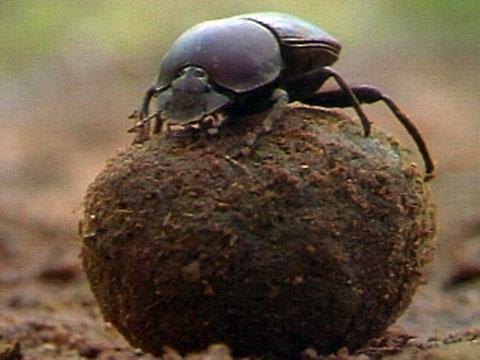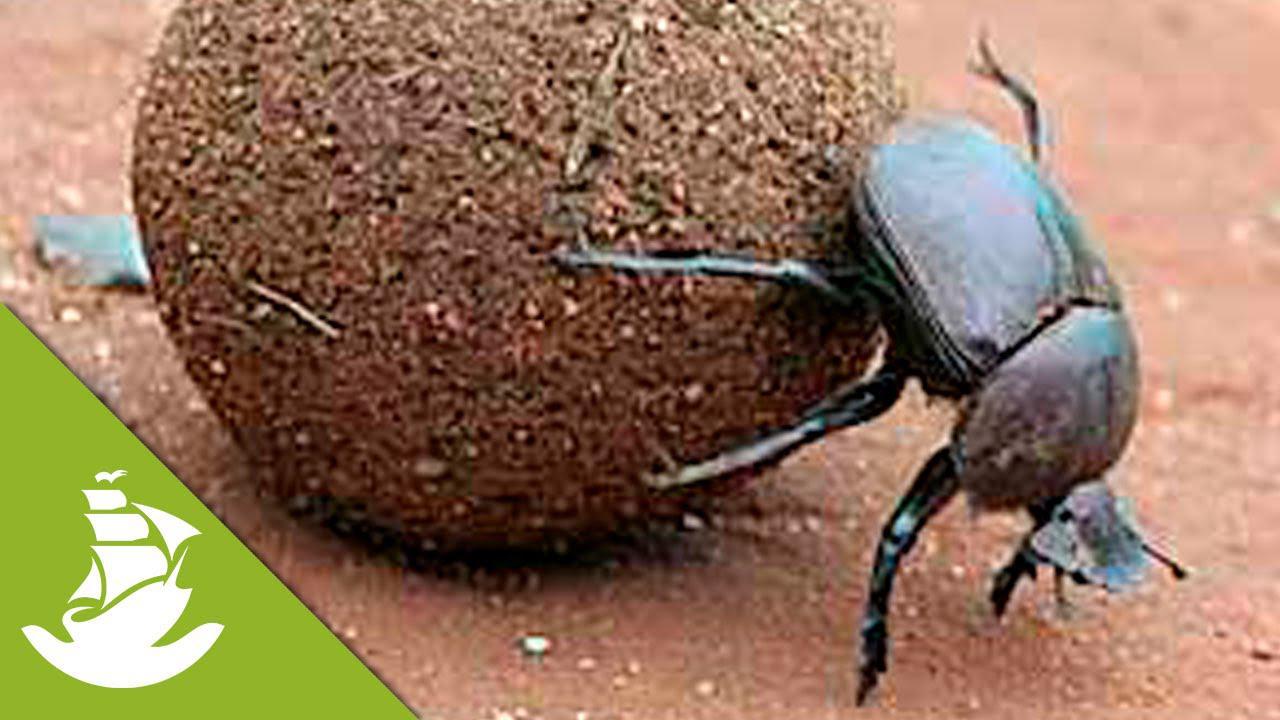The first image is the image on the left, the second image is the image on the right. Considering the images on both sides, is "In one of the images, more than one beetle is seen, interacting with the 'ball'." valid? Answer yes or no. No. The first image is the image on the left, the second image is the image on the right. Analyze the images presented: Is the assertion "There are no more than two dung beetles." valid? Answer yes or no. Yes. The first image is the image on the left, the second image is the image on the right. Examine the images to the left and right. Is the description "An image shows a beetle standing directly on top of a dung ball, with its body horizontal." accurate? Answer yes or no. Yes. The first image is the image on the left, the second image is the image on the right. For the images shown, is this caption "There is a beetle that that's at the very top of a dungball." true? Answer yes or no. Yes. 